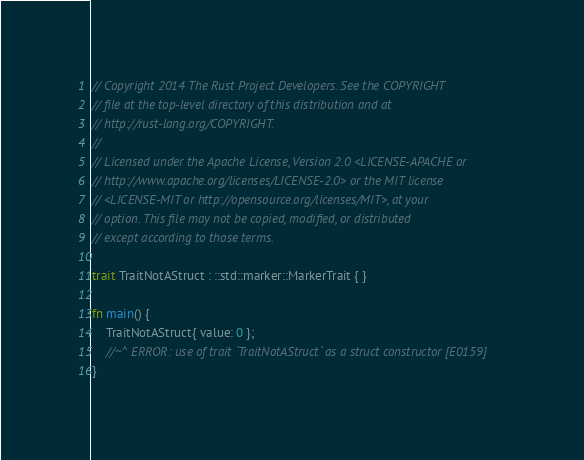Convert code to text. <code><loc_0><loc_0><loc_500><loc_500><_Rust_>// Copyright 2014 The Rust Project Developers. See the COPYRIGHT
// file at the top-level directory of this distribution and at
// http://rust-lang.org/COPYRIGHT.
//
// Licensed under the Apache License, Version 2.0 <LICENSE-APACHE or
// http://www.apache.org/licenses/LICENSE-2.0> or the MIT license
// <LICENSE-MIT or http://opensource.org/licenses/MIT>, at your
// option. This file may not be copied, modified, or distributed
// except according to those terms.

trait TraitNotAStruct : ::std::marker::MarkerTrait { }

fn main() {
    TraitNotAStruct{ value: 0 };
    //~^ ERROR: use of trait `TraitNotAStruct` as a struct constructor [E0159]
}

</code> 